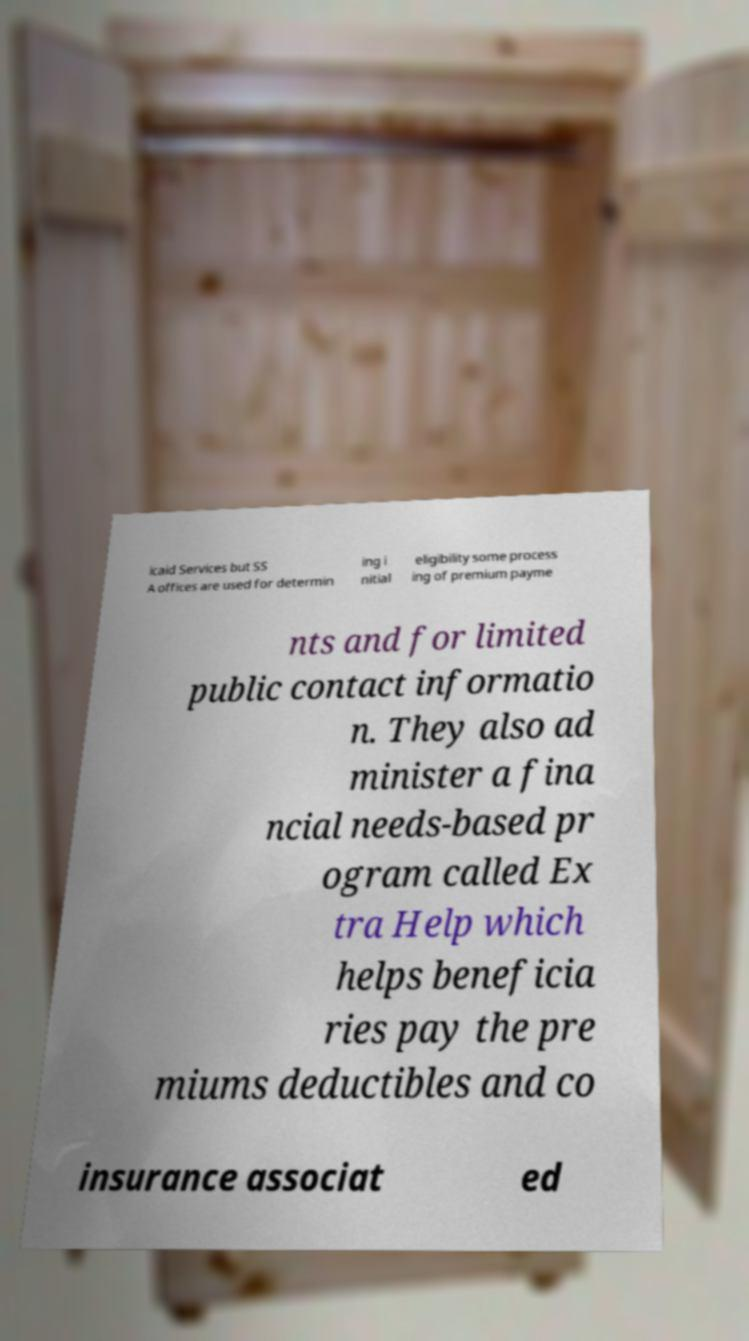For documentation purposes, I need the text within this image transcribed. Could you provide that? icaid Services but SS A offices are used for determin ing i nitial eligibility some process ing of premium payme nts and for limited public contact informatio n. They also ad minister a fina ncial needs-based pr ogram called Ex tra Help which helps beneficia ries pay the pre miums deductibles and co insurance associat ed 